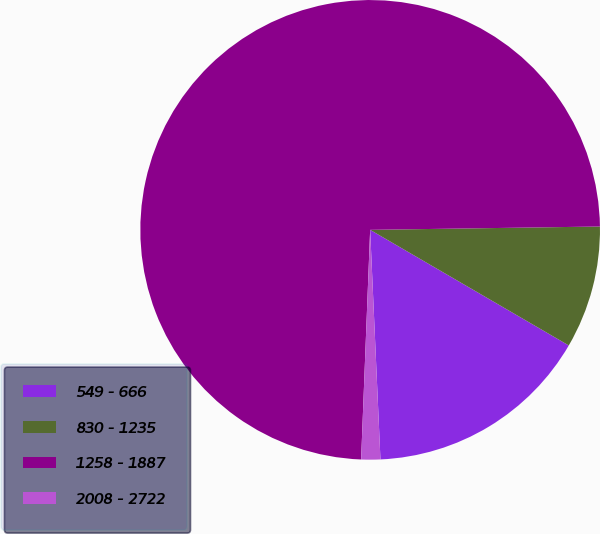Convert chart. <chart><loc_0><loc_0><loc_500><loc_500><pie_chart><fcel>549 - 666<fcel>830 - 1235<fcel>1258 - 1887<fcel>2008 - 2722<nl><fcel>15.9%<fcel>8.62%<fcel>74.15%<fcel>1.34%<nl></chart> 